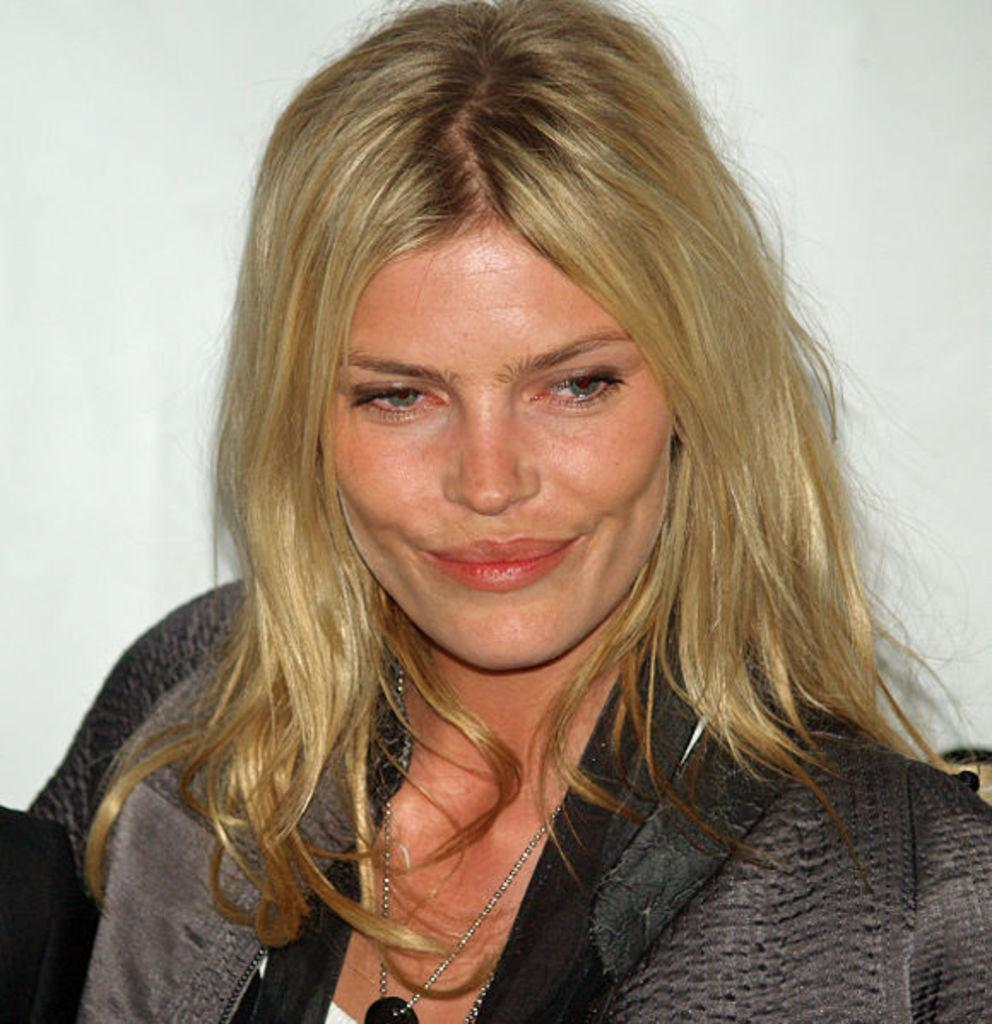Who is present in the image? There is a lady in the image. What is the lady wearing in the image? The lady is wearing a chain in the image. What can be seen in the background of the image? There is a white wall in the background of the image. How many goldfish are swimming in the cast in the image? There are no goldfish or cast present in the image. 